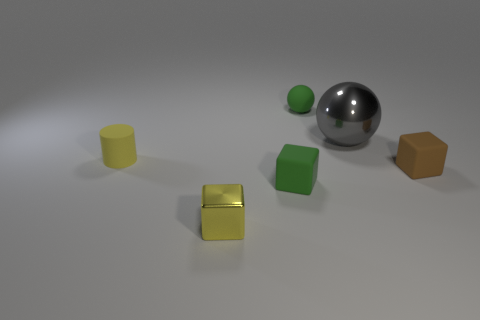Are there more metallic things to the right of the big metallic ball than small green rubber cubes behind the brown matte cube?
Your answer should be very brief. No. There is a tiny green thing that is in front of the gray metal ball; what material is it?
Give a very brief answer. Rubber. Do the yellow matte object and the yellow shiny thing have the same shape?
Give a very brief answer. No. Are there any other things of the same color as the rubber ball?
Keep it short and to the point. Yes. What is the color of the other shiny thing that is the same shape as the brown thing?
Your answer should be compact. Yellow. Are there more green objects that are on the left side of the tiny yellow matte object than big gray objects?
Offer a terse response. No. The thing behind the big metal object is what color?
Give a very brief answer. Green. Is the size of the cylinder the same as the green rubber ball?
Provide a short and direct response. Yes. The matte cylinder has what size?
Your answer should be very brief. Small. What is the shape of the metallic object that is the same color as the rubber cylinder?
Your answer should be compact. Cube. 